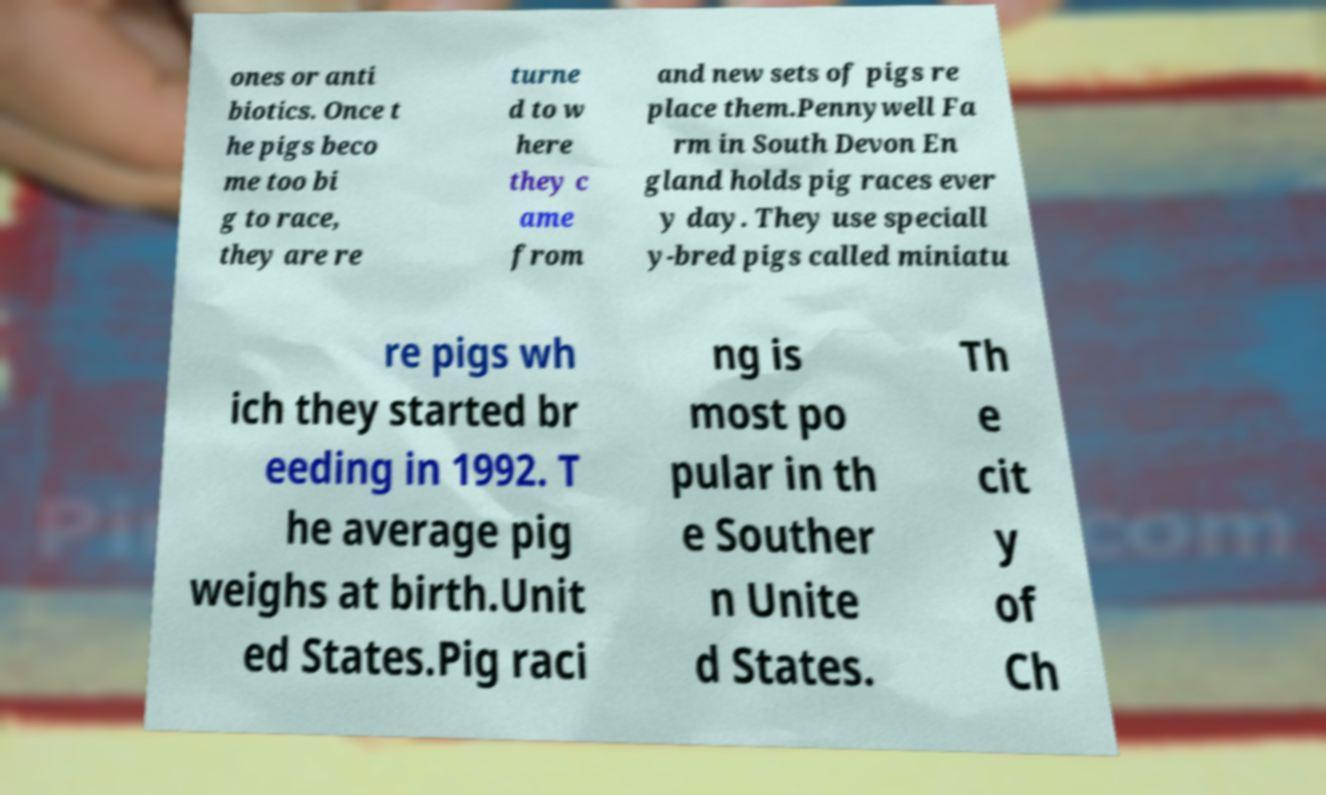There's text embedded in this image that I need extracted. Can you transcribe it verbatim? ones or anti biotics. Once t he pigs beco me too bi g to race, they are re turne d to w here they c ame from and new sets of pigs re place them.Pennywell Fa rm in South Devon En gland holds pig races ever y day. They use speciall y-bred pigs called miniatu re pigs wh ich they started br eeding in 1992. T he average pig weighs at birth.Unit ed States.Pig raci ng is most po pular in th e Souther n Unite d States. Th e cit y of Ch 